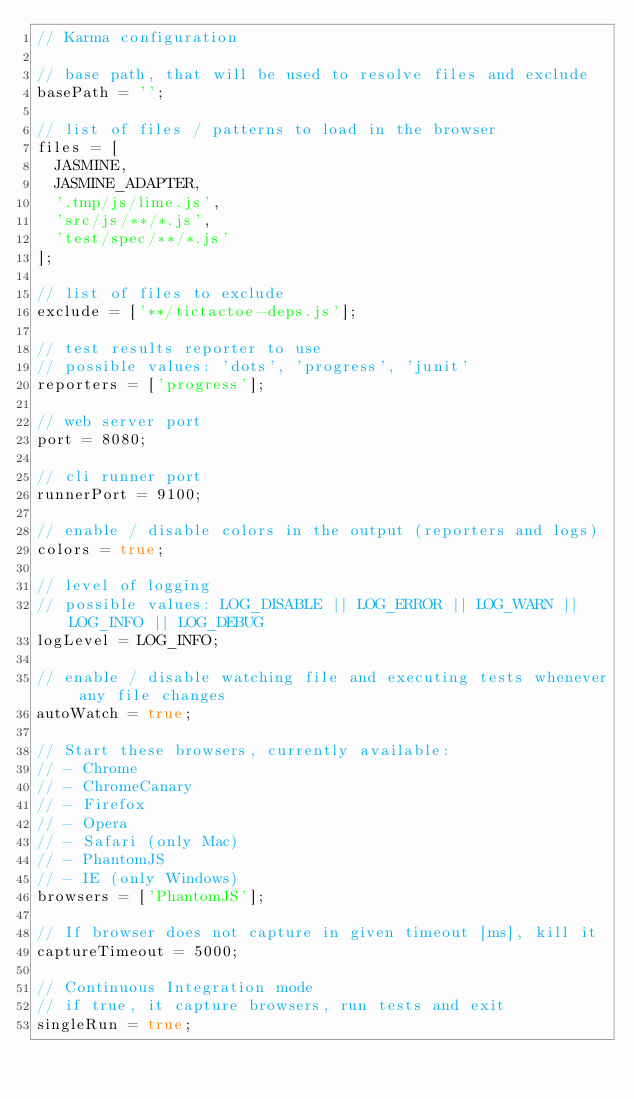<code> <loc_0><loc_0><loc_500><loc_500><_JavaScript_>// Karma configuration

// base path, that will be used to resolve files and exclude
basePath = '';

// list of files / patterns to load in the browser
files = [
  JASMINE,
  JASMINE_ADAPTER,
  '.tmp/js/lime.js',
  'src/js/**/*.js',
  'test/spec/**/*.js'
];

// list of files to exclude
exclude = ['**/tictactoe-deps.js'];

// test results reporter to use
// possible values: 'dots', 'progress', 'junit'
reporters = ['progress'];

// web server port
port = 8080;

// cli runner port
runnerPort = 9100;

// enable / disable colors in the output (reporters and logs)
colors = true;

// level of logging
// possible values: LOG_DISABLE || LOG_ERROR || LOG_WARN || LOG_INFO || LOG_DEBUG
logLevel = LOG_INFO;

// enable / disable watching file and executing tests whenever any file changes
autoWatch = true;

// Start these browsers, currently available:
// - Chrome
// - ChromeCanary
// - Firefox
// - Opera
// - Safari (only Mac)
// - PhantomJS
// - IE (only Windows)
browsers = ['PhantomJS'];

// If browser does not capture in given timeout [ms], kill it
captureTimeout = 5000;

// Continuous Integration mode
// if true, it capture browsers, run tests and exit
singleRun = true;
</code> 